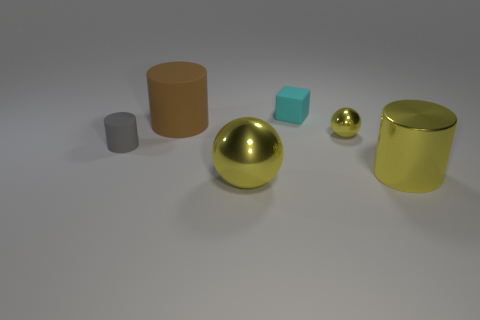The small rubber cylinder is what color?
Give a very brief answer. Gray. How many small things are brown things or yellow metal balls?
Your answer should be compact. 1. There is a cylinder right of the cube; is it the same size as the matte thing in front of the brown cylinder?
Give a very brief answer. No. The other object that is the same shape as the small yellow shiny object is what size?
Make the answer very short. Large. Is the number of things in front of the small cyan object greater than the number of big metallic spheres right of the big yellow metallic ball?
Make the answer very short. Yes. There is a yellow thing that is both in front of the tiny gray rubber object and right of the large metal sphere; what is its material?
Your response must be concise. Metal. There is another large object that is the same shape as the brown thing; what color is it?
Your answer should be compact. Yellow. The yellow metallic cylinder is what size?
Offer a very short reply. Large. What color is the big metallic thing that is to the right of the rubber object behind the brown cylinder?
Your response must be concise. Yellow. How many small objects are to the right of the brown matte thing and in front of the large matte cylinder?
Keep it short and to the point. 1. 